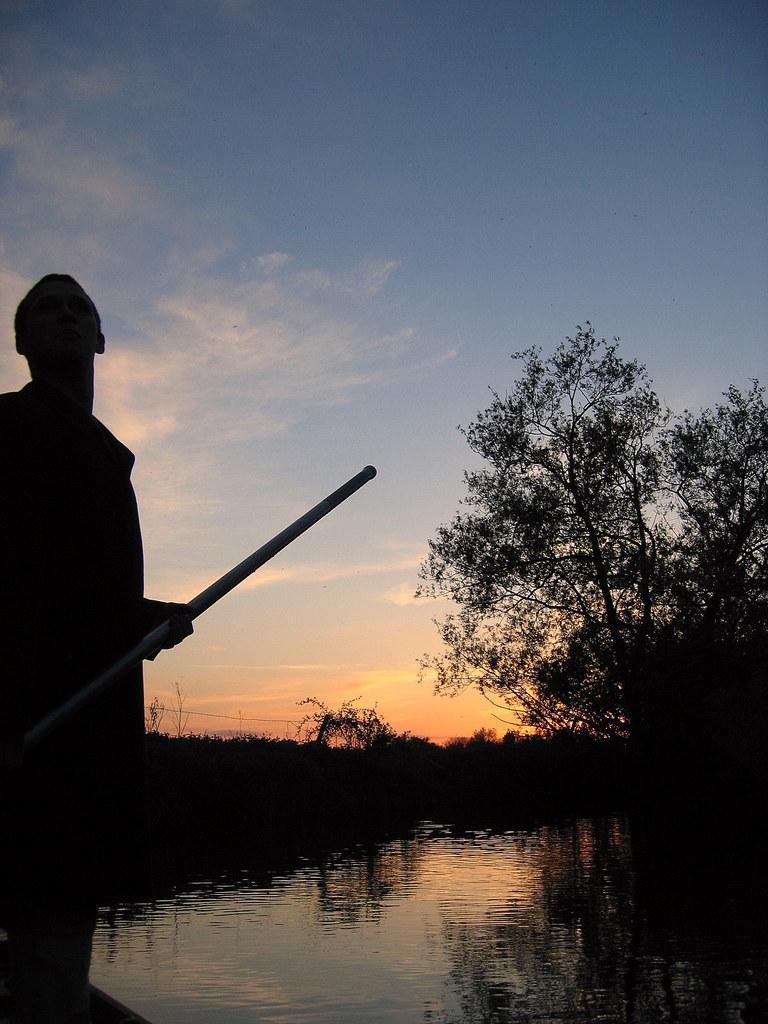How would you summarize this image in a sentence or two? There is a person standing and holding stick and we can see water, trees and sky with clouds. 